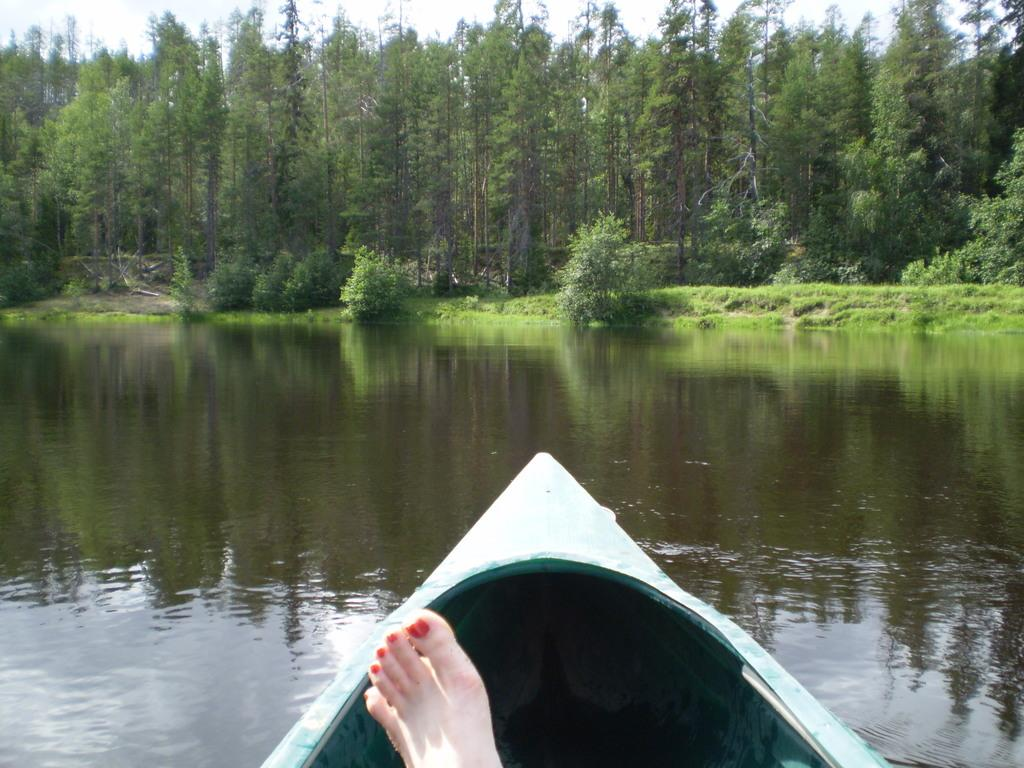What are the persons in the image doing? The persons in the image are sailing on a boat on the river. Where is the boat located in the image? The boat is in the water. What can be seen in the background of the image? There are trees, plants, grass, and the sky visible in the background of the image. What type of lipstick is the boat wearing in the image? The boat is not wearing lipstick, as it is an inanimate object and not capable of wearing makeup. 